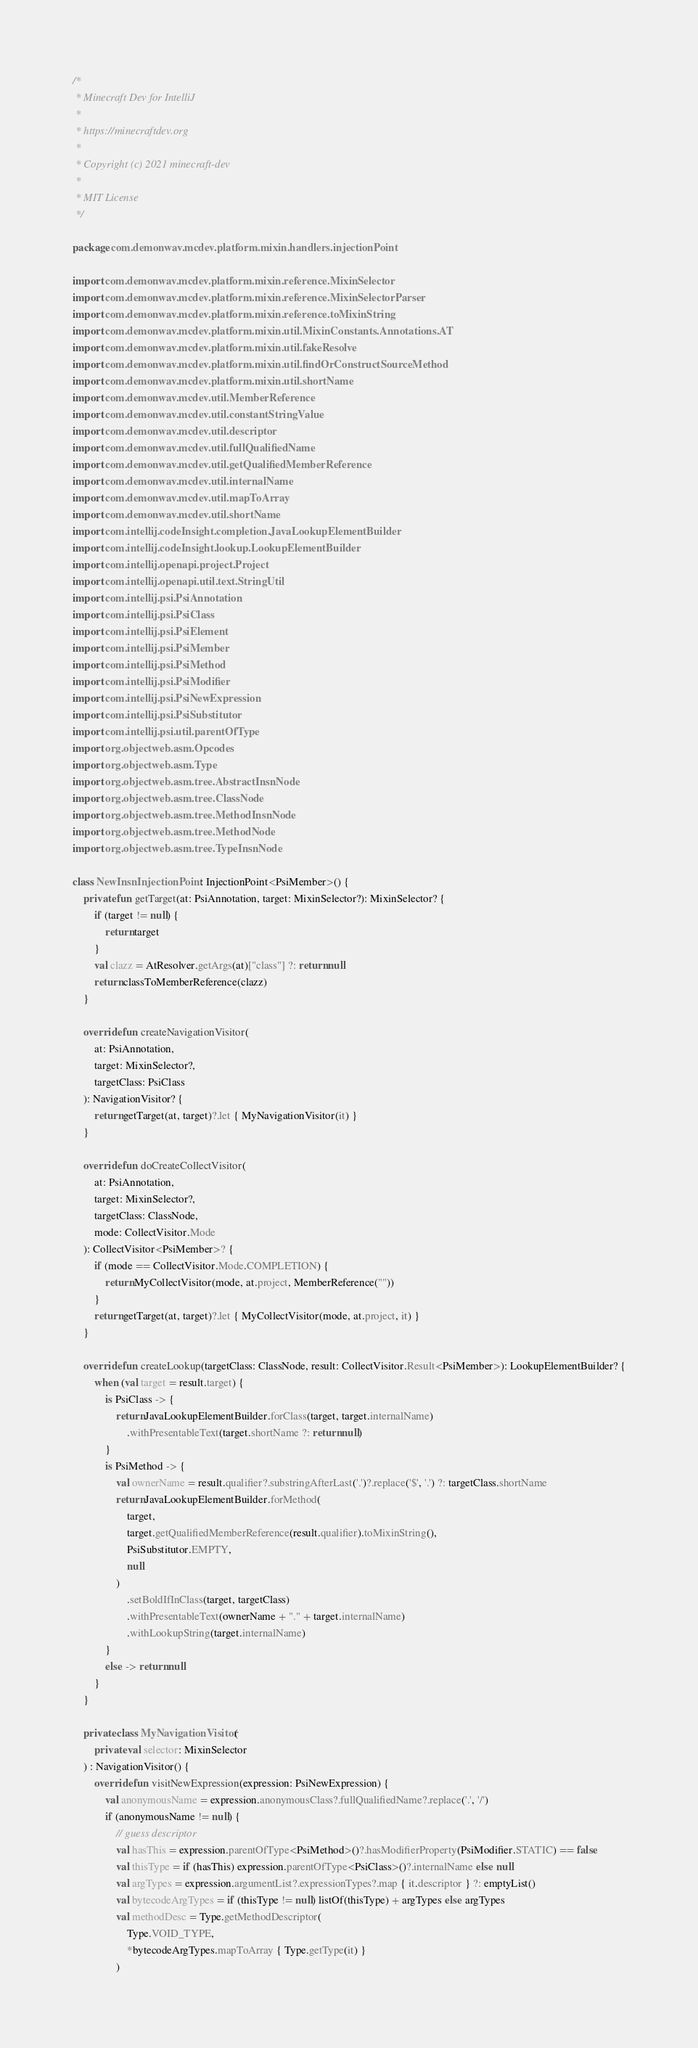<code> <loc_0><loc_0><loc_500><loc_500><_Kotlin_>/*
 * Minecraft Dev for IntelliJ
 *
 * https://minecraftdev.org
 *
 * Copyright (c) 2021 minecraft-dev
 *
 * MIT License
 */

package com.demonwav.mcdev.platform.mixin.handlers.injectionPoint

import com.demonwav.mcdev.platform.mixin.reference.MixinSelector
import com.demonwav.mcdev.platform.mixin.reference.MixinSelectorParser
import com.demonwav.mcdev.platform.mixin.reference.toMixinString
import com.demonwav.mcdev.platform.mixin.util.MixinConstants.Annotations.AT
import com.demonwav.mcdev.platform.mixin.util.fakeResolve
import com.demonwav.mcdev.platform.mixin.util.findOrConstructSourceMethod
import com.demonwav.mcdev.platform.mixin.util.shortName
import com.demonwav.mcdev.util.MemberReference
import com.demonwav.mcdev.util.constantStringValue
import com.demonwav.mcdev.util.descriptor
import com.demonwav.mcdev.util.fullQualifiedName
import com.demonwav.mcdev.util.getQualifiedMemberReference
import com.demonwav.mcdev.util.internalName
import com.demonwav.mcdev.util.mapToArray
import com.demonwav.mcdev.util.shortName
import com.intellij.codeInsight.completion.JavaLookupElementBuilder
import com.intellij.codeInsight.lookup.LookupElementBuilder
import com.intellij.openapi.project.Project
import com.intellij.openapi.util.text.StringUtil
import com.intellij.psi.PsiAnnotation
import com.intellij.psi.PsiClass
import com.intellij.psi.PsiElement
import com.intellij.psi.PsiMember
import com.intellij.psi.PsiMethod
import com.intellij.psi.PsiModifier
import com.intellij.psi.PsiNewExpression
import com.intellij.psi.PsiSubstitutor
import com.intellij.psi.util.parentOfType
import org.objectweb.asm.Opcodes
import org.objectweb.asm.Type
import org.objectweb.asm.tree.AbstractInsnNode
import org.objectweb.asm.tree.ClassNode
import org.objectweb.asm.tree.MethodInsnNode
import org.objectweb.asm.tree.MethodNode
import org.objectweb.asm.tree.TypeInsnNode

class NewInsnInjectionPoint : InjectionPoint<PsiMember>() {
    private fun getTarget(at: PsiAnnotation, target: MixinSelector?): MixinSelector? {
        if (target != null) {
            return target
        }
        val clazz = AtResolver.getArgs(at)["class"] ?: return null
        return classToMemberReference(clazz)
    }

    override fun createNavigationVisitor(
        at: PsiAnnotation,
        target: MixinSelector?,
        targetClass: PsiClass
    ): NavigationVisitor? {
        return getTarget(at, target)?.let { MyNavigationVisitor(it) }
    }

    override fun doCreateCollectVisitor(
        at: PsiAnnotation,
        target: MixinSelector?,
        targetClass: ClassNode,
        mode: CollectVisitor.Mode
    ): CollectVisitor<PsiMember>? {
        if (mode == CollectVisitor.Mode.COMPLETION) {
            return MyCollectVisitor(mode, at.project, MemberReference(""))
        }
        return getTarget(at, target)?.let { MyCollectVisitor(mode, at.project, it) }
    }

    override fun createLookup(targetClass: ClassNode, result: CollectVisitor.Result<PsiMember>): LookupElementBuilder? {
        when (val target = result.target) {
            is PsiClass -> {
                return JavaLookupElementBuilder.forClass(target, target.internalName)
                    .withPresentableText(target.shortName ?: return null)
            }
            is PsiMethod -> {
                val ownerName = result.qualifier?.substringAfterLast('.')?.replace('$', '.') ?: targetClass.shortName
                return JavaLookupElementBuilder.forMethod(
                    target,
                    target.getQualifiedMemberReference(result.qualifier).toMixinString(),
                    PsiSubstitutor.EMPTY,
                    null
                )
                    .setBoldIfInClass(target, targetClass)
                    .withPresentableText(ownerName + "." + target.internalName)
                    .withLookupString(target.internalName)
            }
            else -> return null
        }
    }

    private class MyNavigationVisitor(
        private val selector: MixinSelector
    ) : NavigationVisitor() {
        override fun visitNewExpression(expression: PsiNewExpression) {
            val anonymousName = expression.anonymousClass?.fullQualifiedName?.replace('.', '/')
            if (anonymousName != null) {
                // guess descriptor
                val hasThis = expression.parentOfType<PsiMethod>()?.hasModifierProperty(PsiModifier.STATIC) == false
                val thisType = if (hasThis) expression.parentOfType<PsiClass>()?.internalName else null
                val argTypes = expression.argumentList?.expressionTypes?.map { it.descriptor } ?: emptyList()
                val bytecodeArgTypes = if (thisType != null) listOf(thisType) + argTypes else argTypes
                val methodDesc = Type.getMethodDescriptor(
                    Type.VOID_TYPE,
                    *bytecodeArgTypes.mapToArray { Type.getType(it) }
                )</code> 